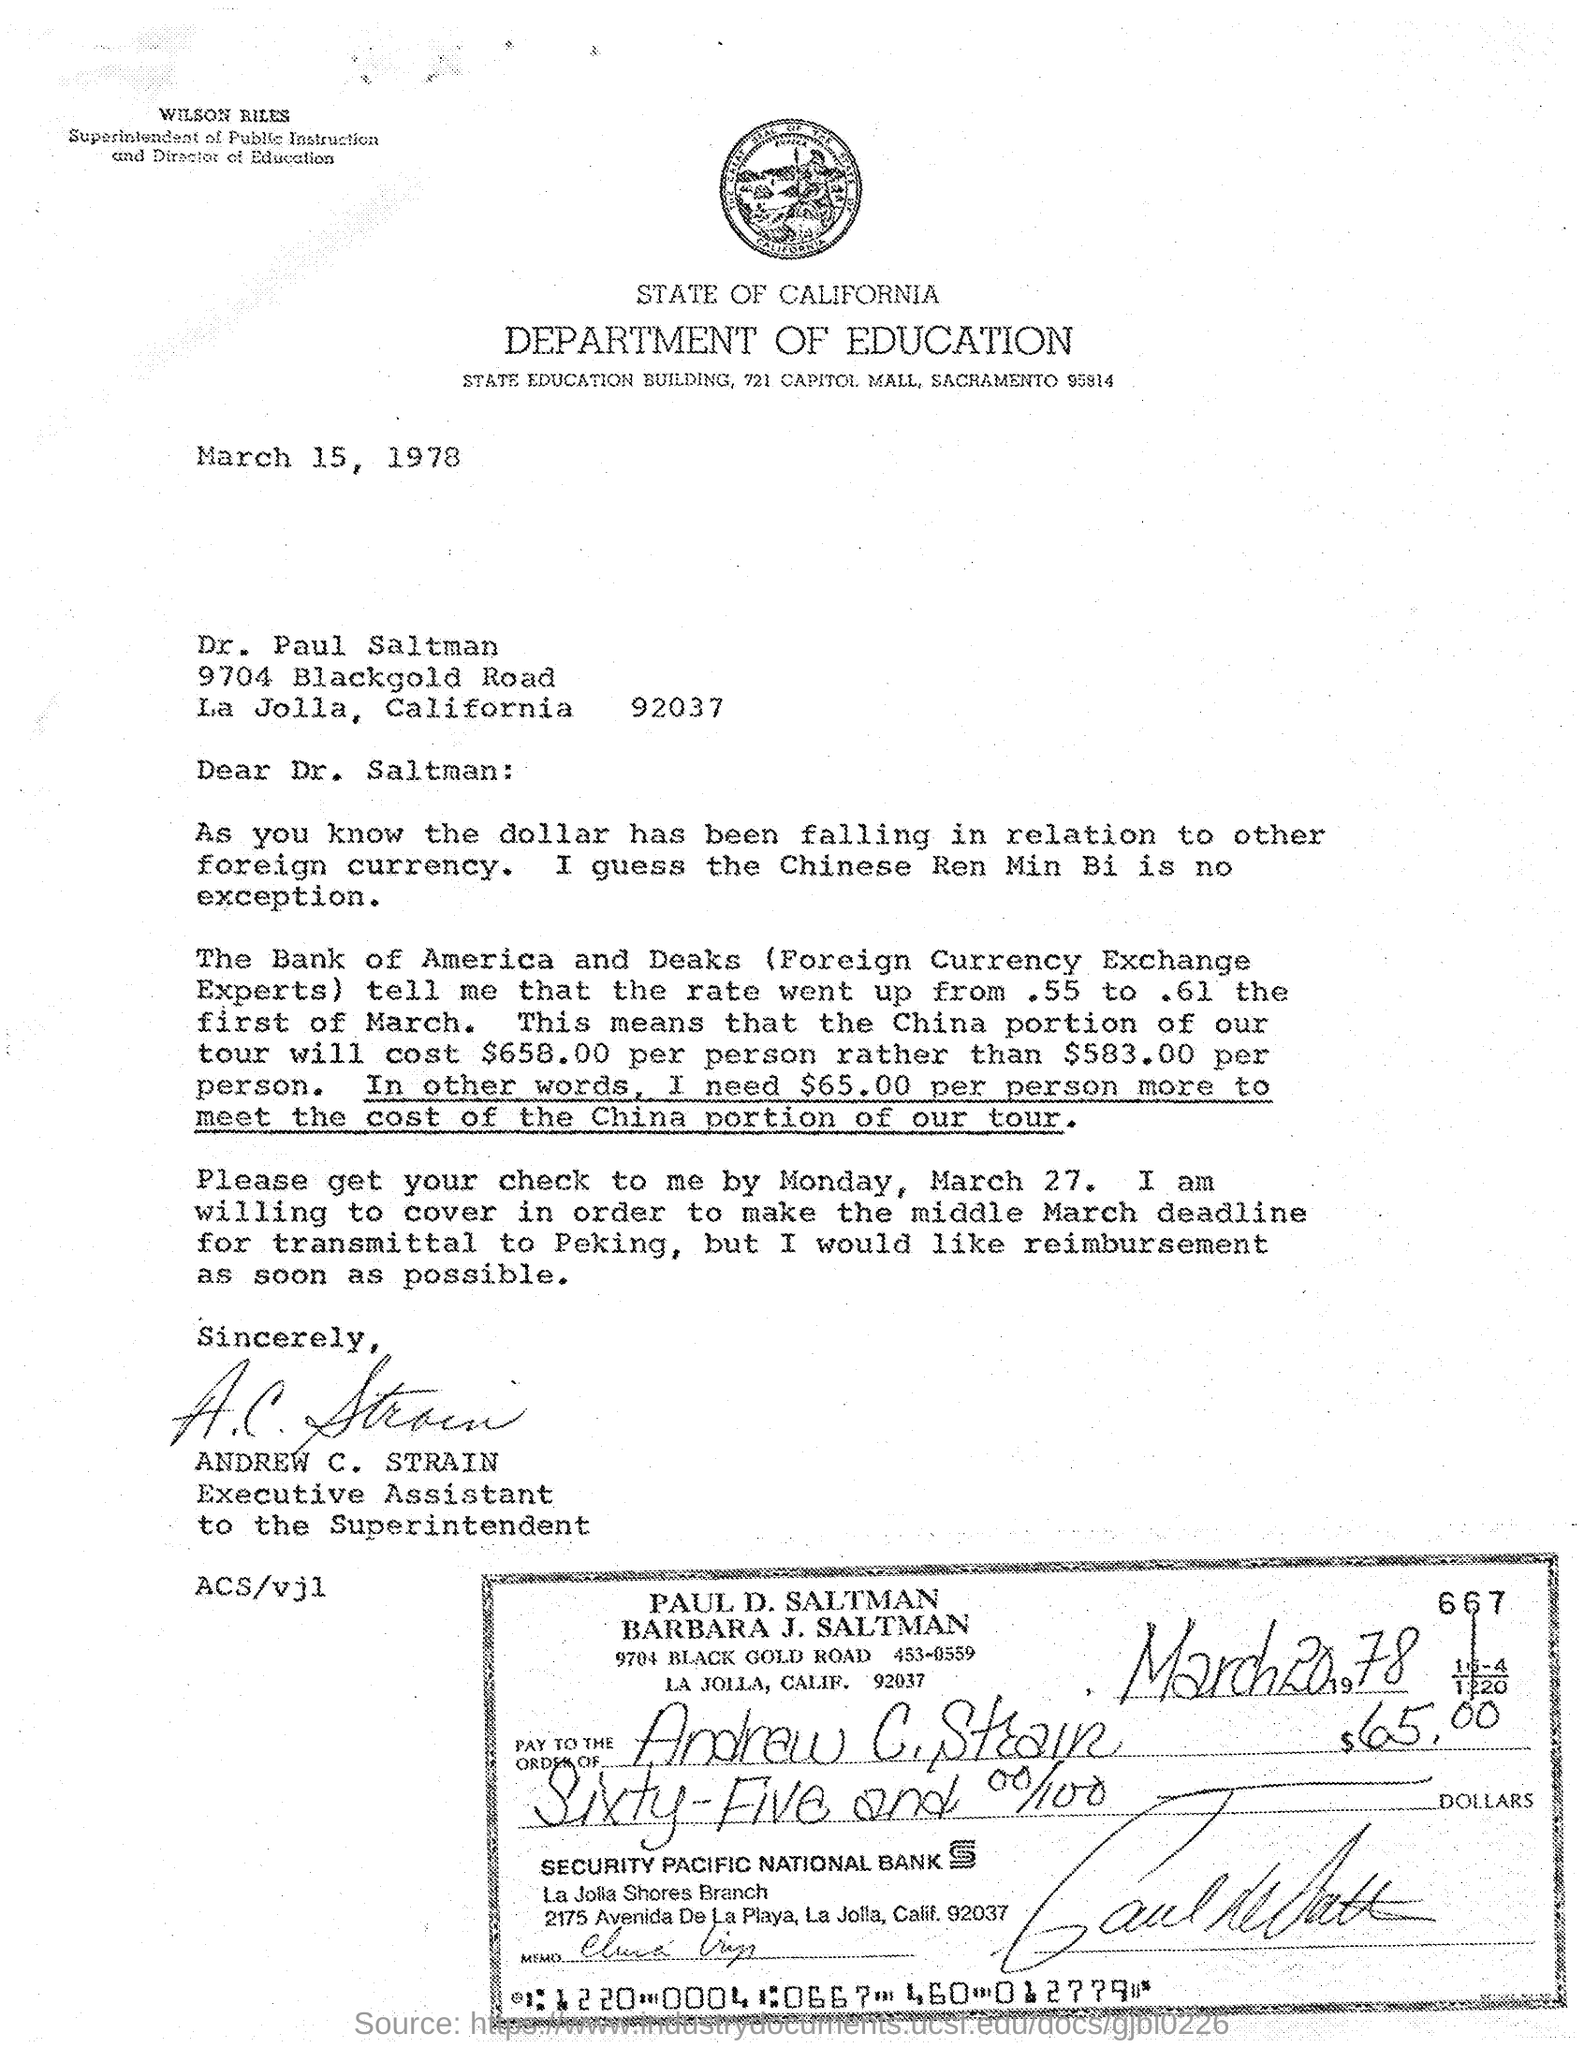Who is the superintendent of public instruction ?
Ensure brevity in your answer.  Wilson Riles. Who is the executive assistant ?
Your answer should be very brief. Andrew C. Strain. From which department the letter is from ?
Provide a short and direct response. EDUCATION. Which bank is mentioned in the cheque ?
Provide a short and direct response. SECURITY PACIFIC NATIONAL BANK. 